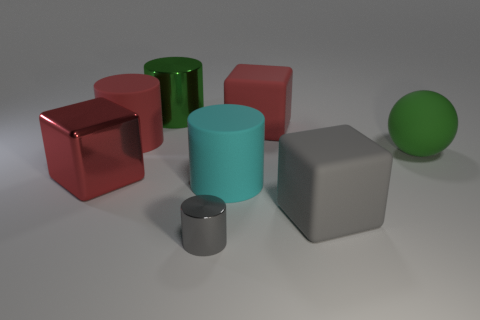What number of other things are the same color as the small metallic thing?
Provide a short and direct response. 1. What number of things are both on the left side of the red rubber block and in front of the large green matte thing?
Your answer should be compact. 3. The large block in front of the metal cube is what color?
Provide a short and direct response. Gray. There is a gray thing that is made of the same material as the large green cylinder; what size is it?
Provide a succinct answer. Small. What number of large blocks are left of the big red thing behind the large red matte cylinder?
Ensure brevity in your answer.  1. There is a small metallic cylinder; how many big red matte objects are left of it?
Your answer should be very brief. 1. What color is the large cube to the left of the green thing that is behind the large object that is to the right of the big gray object?
Keep it short and to the point. Red. There is a block on the left side of the small thing; is it the same color as the big matte thing to the left of the gray metal cylinder?
Your response must be concise. Yes. There is a green object to the right of the big cylinder to the right of the small object; what shape is it?
Provide a short and direct response. Sphere. Are there any green rubber spheres of the same size as the cyan matte cylinder?
Ensure brevity in your answer.  Yes. 